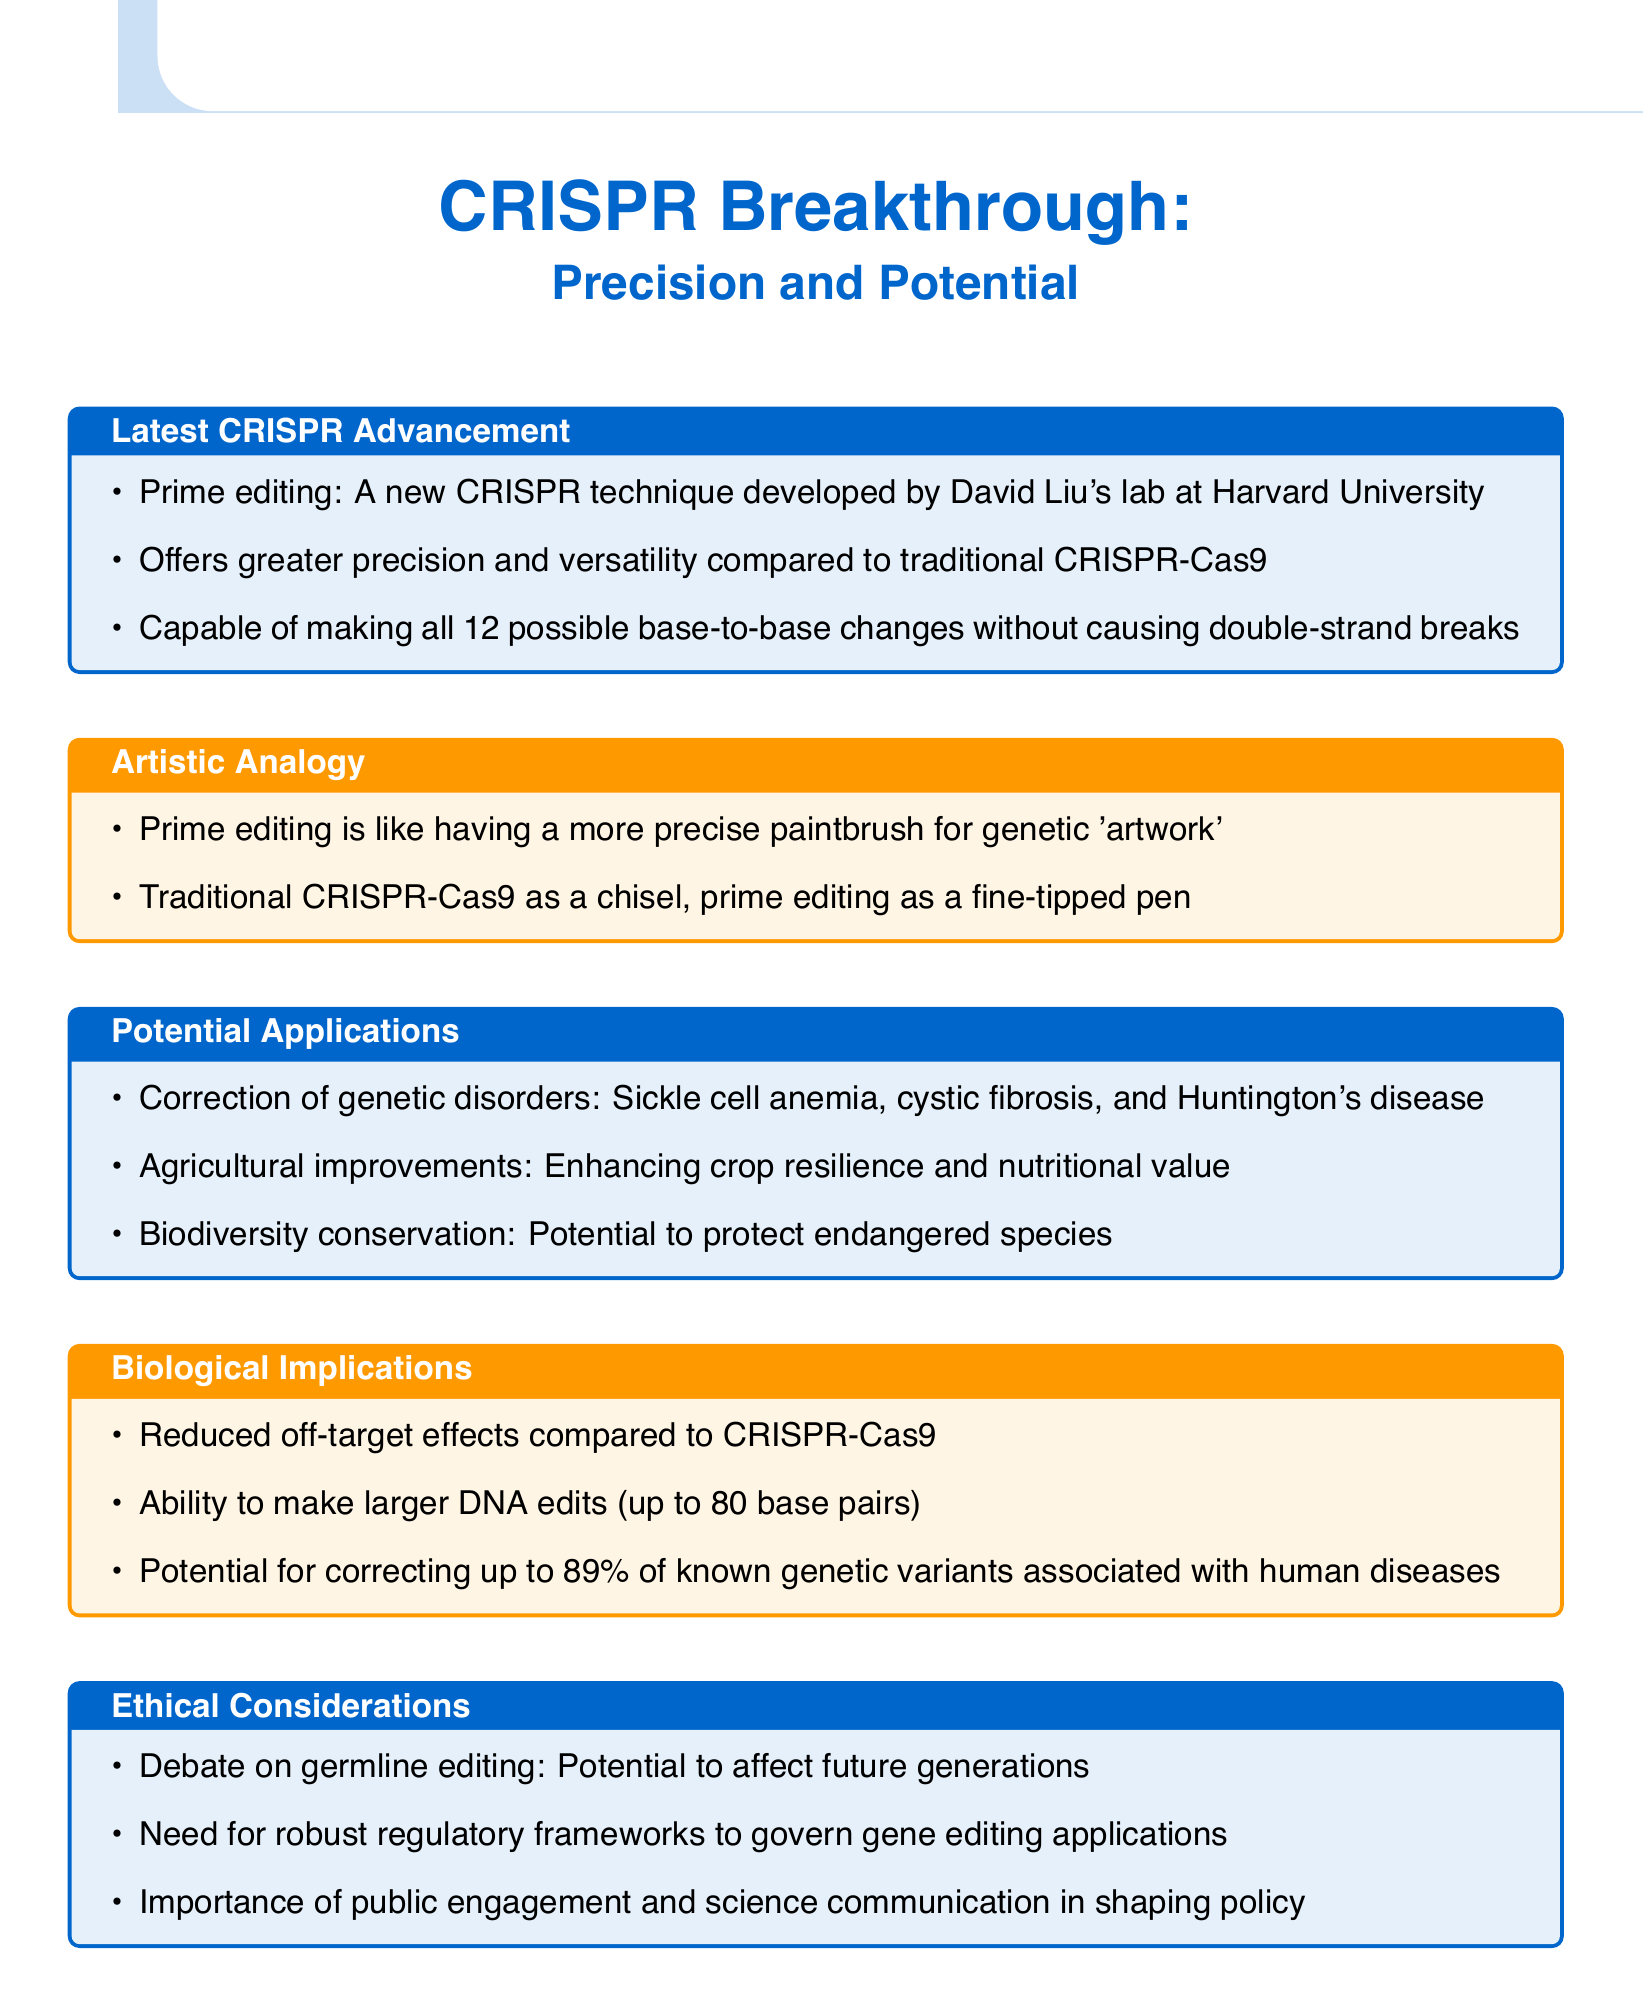What is the name of the new CRISPR technique? The document identifies the new CRISPR technique as "Prime editing," developed by David Liu's lab at Harvard University.
Answer: Prime editing Who developed the latest CRISPR technique? The document states that the latest CRISPR technique was developed by "David Liu's lab at Harvard University."
Answer: David Liu What is the maximum size of DNA edits that prime editing can make? The document mentions that prime editing has the ability to make larger DNA edits of "up to 80 base pairs."
Answer: 80 base pairs Which genetic disorders can be corrected using prime editing? The document lists specific disorders that can be corrected, including "sickle cell anemia, cystic fibrosis, and Huntington's disease."
Answer: Sickle cell anemia, cystic fibrosis, and Huntington's disease What are traditional CRISPR-Cas9 and prime editing compared to in the document? The document uses artistic analogies to compare traditional CRISPR-Cas9 to a "chisel" and prime editing to a "fine-tipped pen."
Answer: Chisel and fine-tipped pen What is a potential risk of germline editing mentioned in the document? The document notes the potential risk of germline editing as having the capacity to "affect future generations."
Answer: Affect future generations How much of known genetic variants associated with diseases can prime editing potentially correct? The document claims that prime editing has the potential for correcting "up to 89% of known genetic variants associated with human diseases."
Answer: Up to 89% What is a significant benefit of prime editing compared to traditional CRISPR-Cas9? The document highlights a specific benefit of prime editing as having "reduced off-target effects compared to CRISPR-Cas9."
Answer: Reduced off-target effects What is emphasized as important for shaping policy regarding gene editing? The document underscores the importance of "public engagement and science communication" in shaping policy regarding gene editing applications.
Answer: Public engagement and science communication 